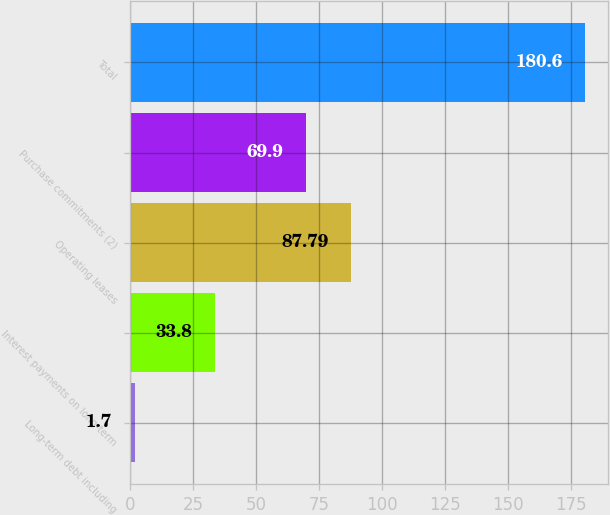<chart> <loc_0><loc_0><loc_500><loc_500><bar_chart><fcel>Long-term debt including<fcel>Interest payments on long-term<fcel>Operating leases<fcel>Purchase commitments (2)<fcel>Total<nl><fcel>1.7<fcel>33.8<fcel>87.79<fcel>69.9<fcel>180.6<nl></chart> 